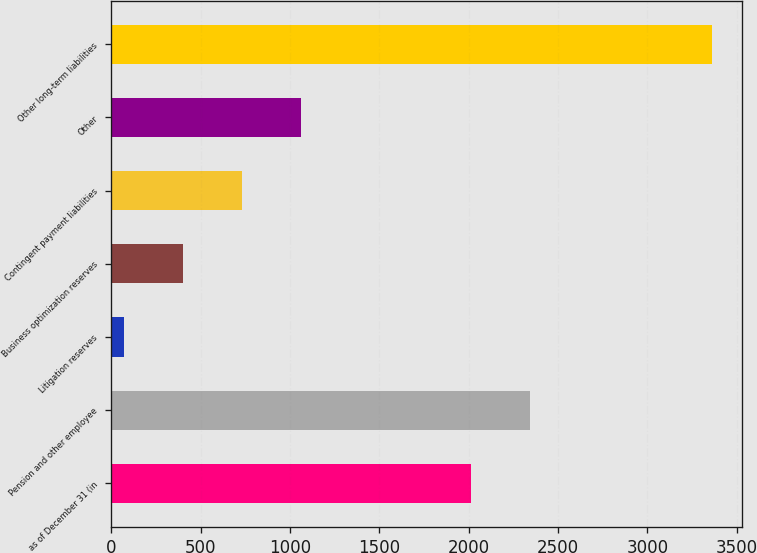<chart> <loc_0><loc_0><loc_500><loc_500><bar_chart><fcel>as of December 31 (in<fcel>Pension and other employee<fcel>Litigation reserves<fcel>Business optimization reserves<fcel>Contingent payment liabilities<fcel>Other<fcel>Other long-term liabilities<nl><fcel>2013<fcel>2342.2<fcel>72<fcel>401.2<fcel>730.4<fcel>1059.6<fcel>3364<nl></chart> 